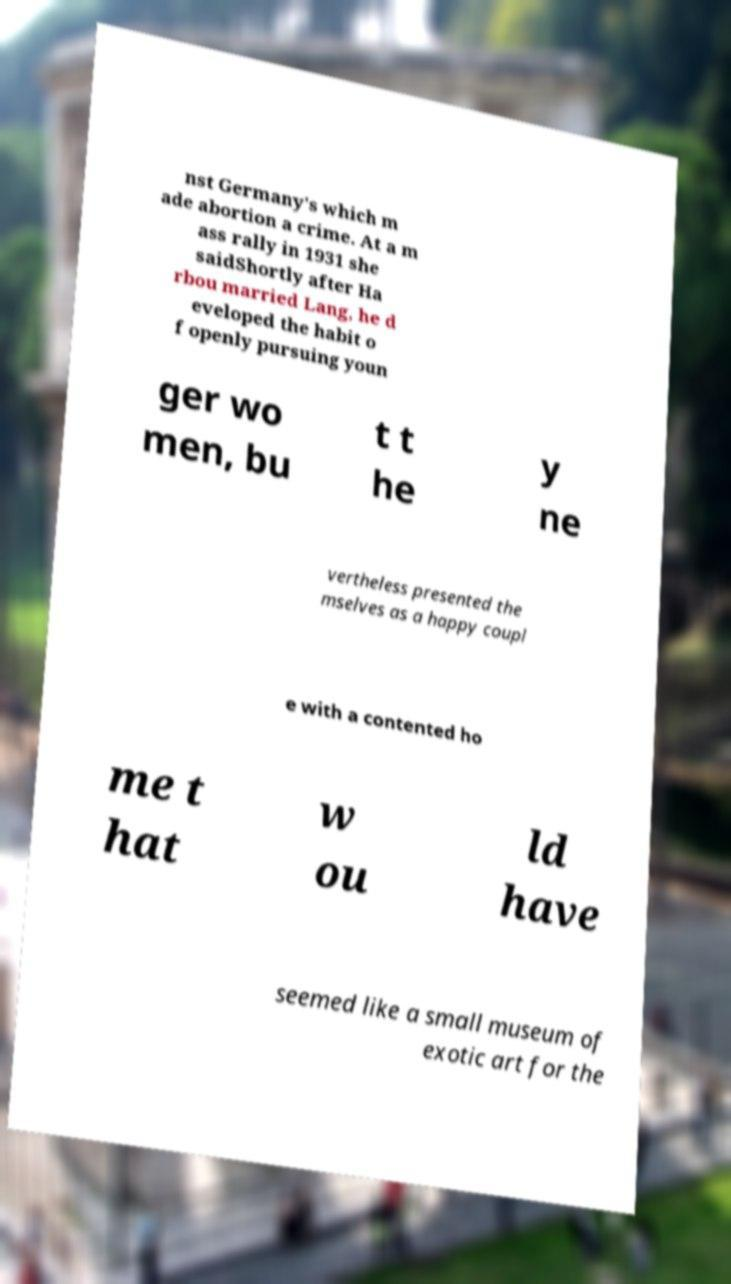Can you read and provide the text displayed in the image?This photo seems to have some interesting text. Can you extract and type it out for me? nst Germany's which m ade abortion a crime. At a m ass rally in 1931 she saidShortly after Ha rbou married Lang, he d eveloped the habit o f openly pursuing youn ger wo men, bu t t he y ne vertheless presented the mselves as a happy coupl e with a contented ho me t hat w ou ld have seemed like a small museum of exotic art for the 